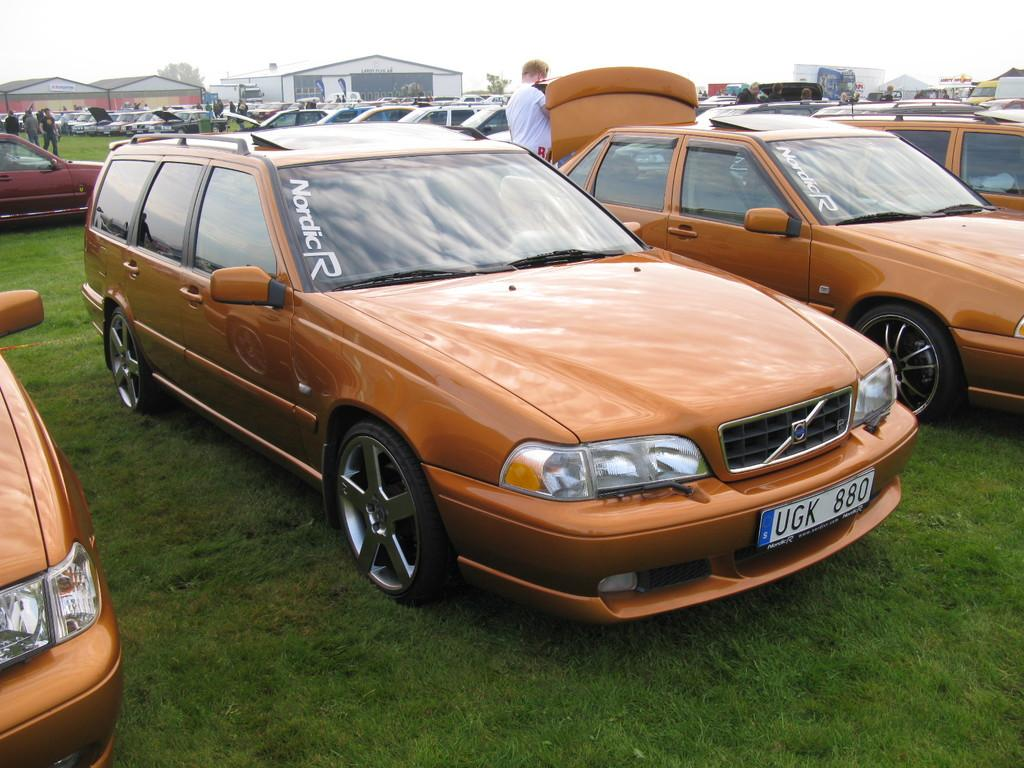What type of vehicles can be seen in the image? There are cars in the image. What structures are present in the image? There are sheds in the image. Can you describe the person in the image? There is a person at the top of the image. What type of lettuce is being regretted by the person in the image? There is no lettuce or indication of regret present in the image. 